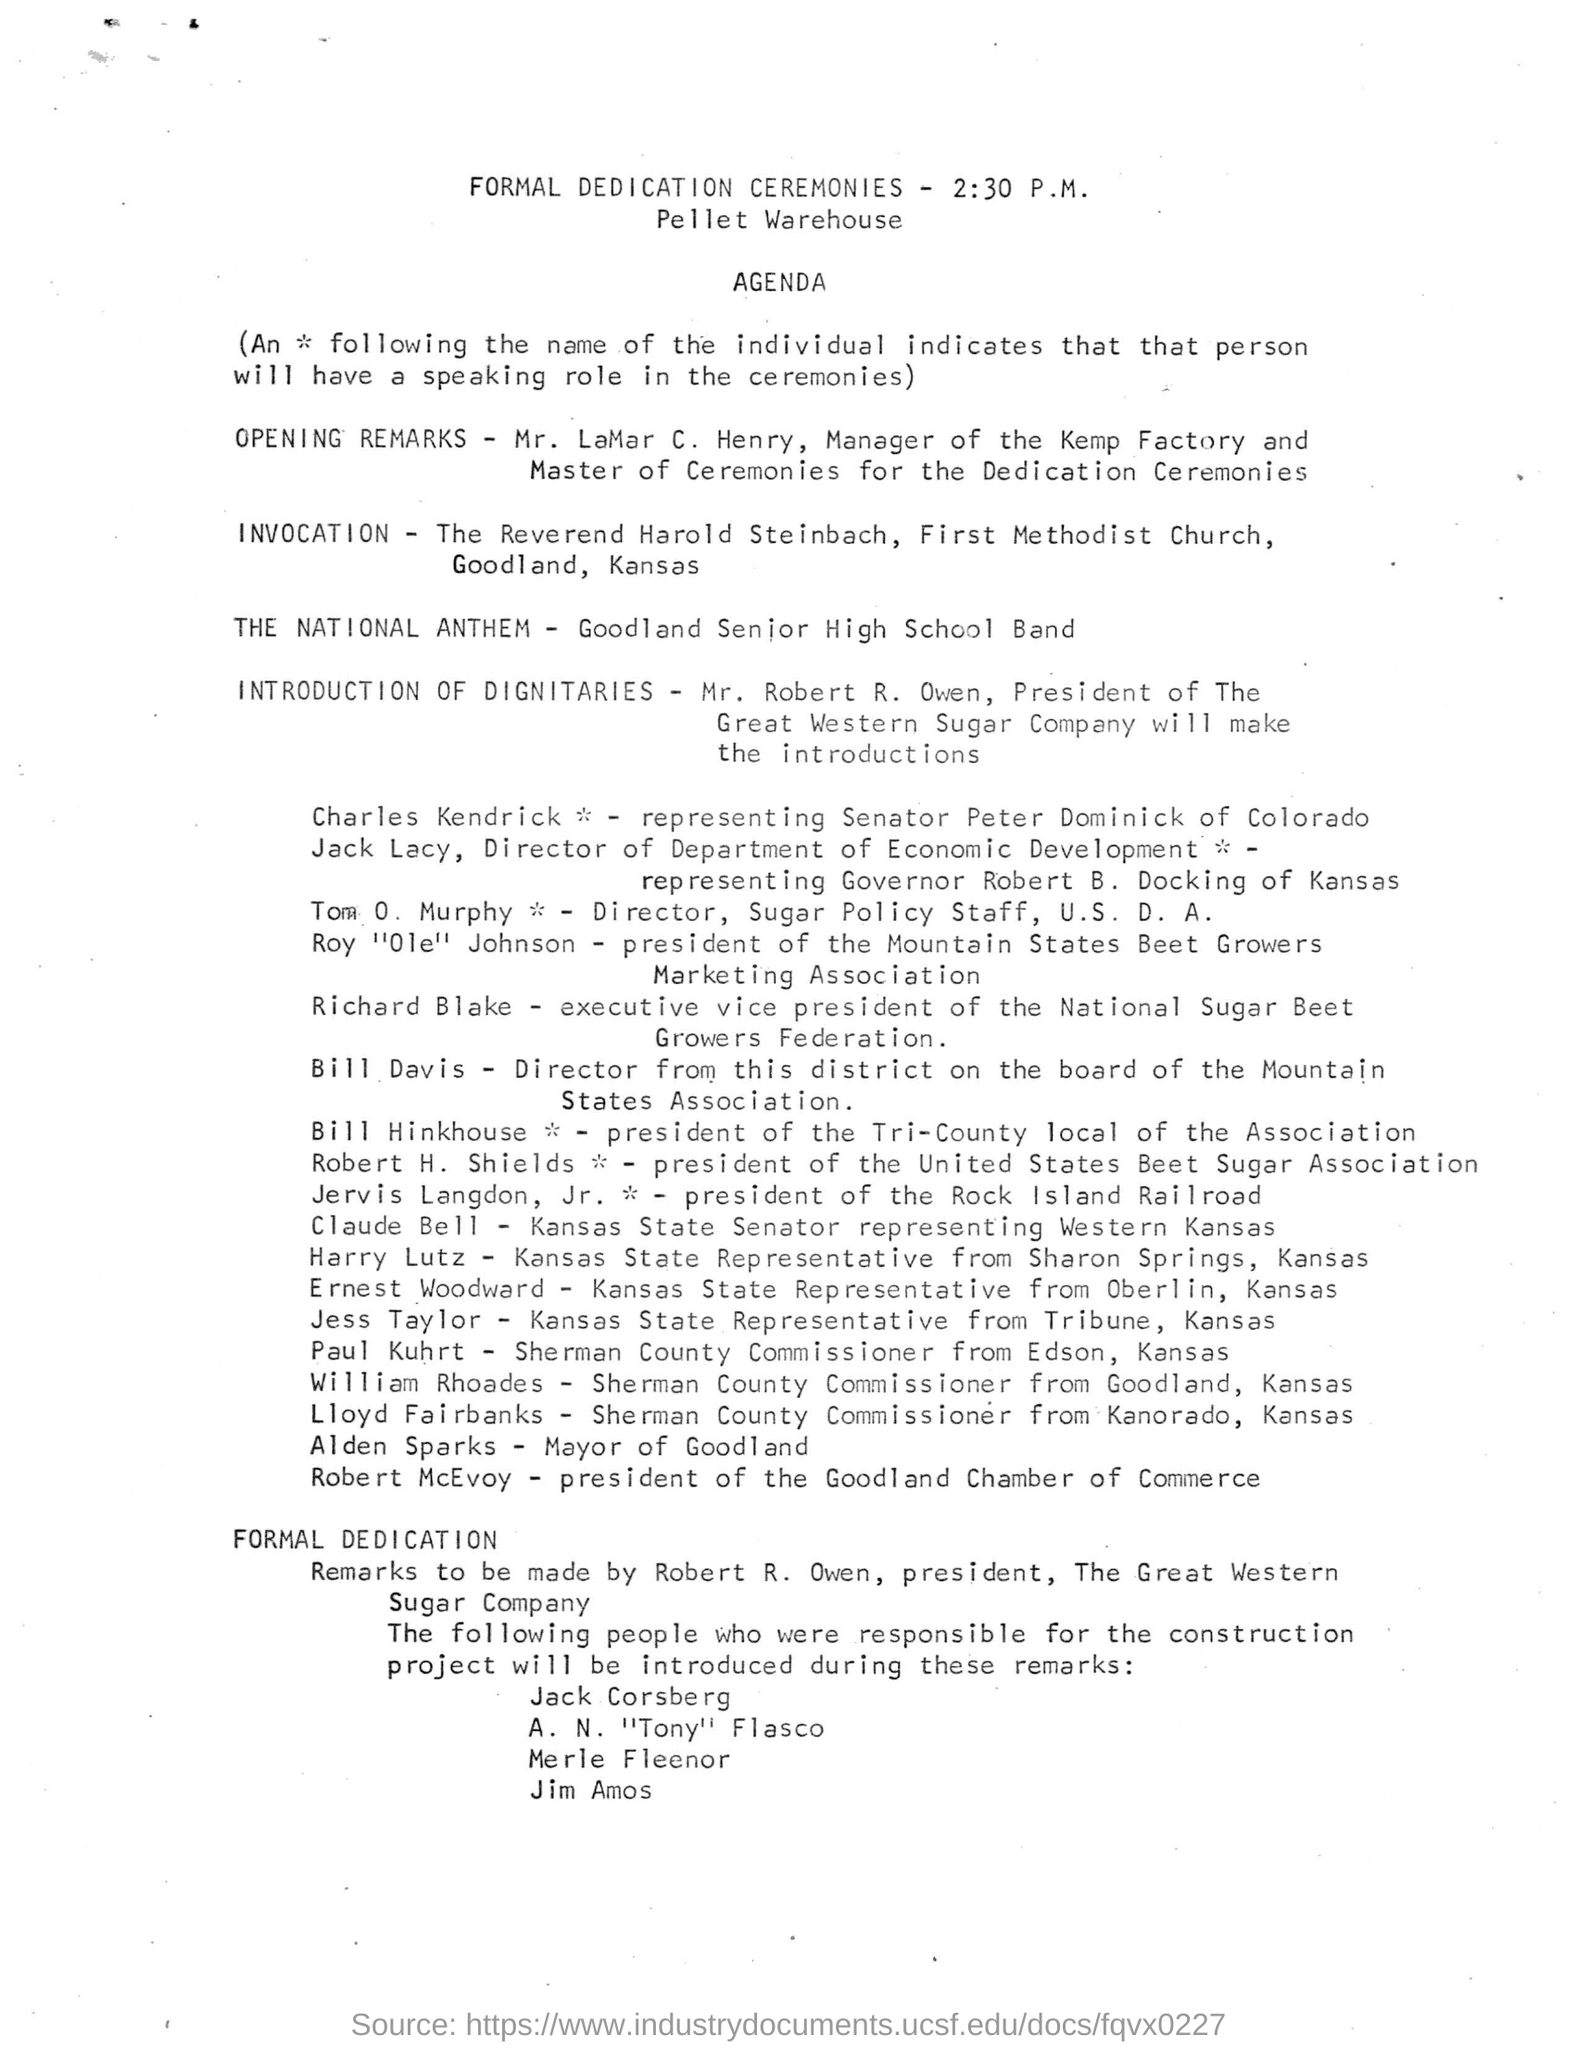When is the formal dedication ceremonies held?
Provide a short and direct response. 2:30 PM. Where is the formal dedication ceremonies held?
Your response must be concise. Pellet Warehouse. Who is presenting the opening remarks as per the agenda?
Make the answer very short. Mr. Lamar C. Henry. Which band is performing the National Anthem?
Give a very brief answer. Goodland Senior High School Band. Who is giving the introduction of Dignitaries as per the agenda?
Your answer should be very brief. Mr. Robert R. Owen. What is the designation of Mr. Robert R. Owen?
Offer a terse response. President. Who is the executive vice president of the National Sugar Beet Growers Federation?
Keep it short and to the point. Richard Blake. What is the designation of Tom O. Murphy?
Make the answer very short. Director, Sugar Policy Staff, U.S. D. A. Who is representing Senator Peter Dominick of Colorado as per the agenda?
Provide a succinct answer. Charles Kendrick. 